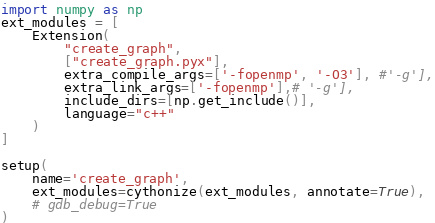Convert code to text. <code><loc_0><loc_0><loc_500><loc_500><_Python_>import numpy as np
ext_modules = [
    Extension(
        "create_graph",
        ["create_graph.pyx"],
        extra_compile_args=['-fopenmp', '-O3'], #'-g'],
        extra_link_args=['-fopenmp'],# '-g'],
        include_dirs=[np.get_include()],
        language="c++"
    )
]

setup(
    name='create_graph',
    ext_modules=cythonize(ext_modules, annotate=True),
    # gdb_debug=True
)
</code> 